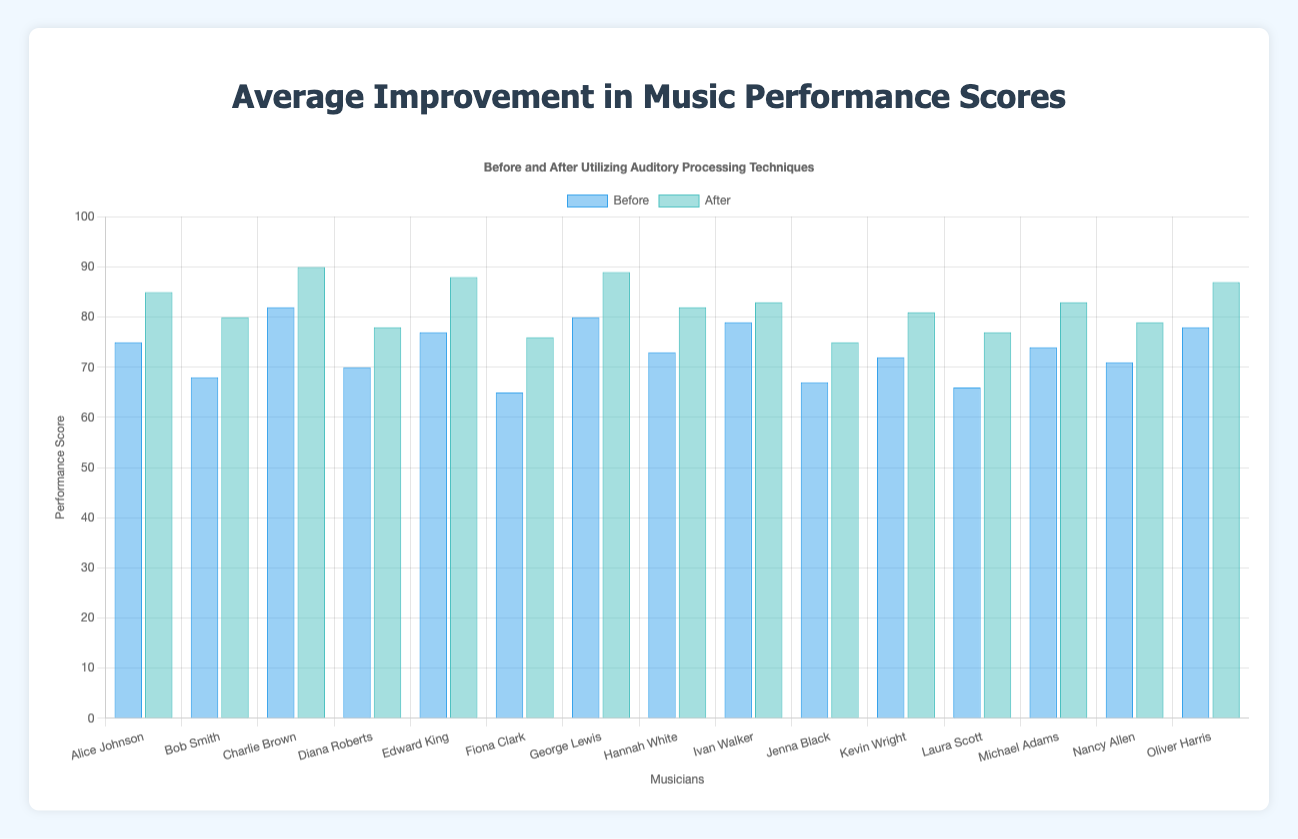Which musician showed the greatest improvement in music performance scores after utilizing auditory processing techniques? To find the greatest improvement, calculate the difference between the "before" and "after" scores for each musician. The largest difference is for Edward King, with an improvement of (88 - 77 = 11 points).
Answer: Edward King What was the average improvement in performance scores for all musicians? To calculate the average improvement, first find the improvement for each musician, sum these improvements, and divide by the number of musicians. Improvements: 10, 12, 8, 8, 11, 11, 9, 9, 4, 8, 9, 11, 9, 8, 9. Sum = 136. Number of musicians = 15. Average improvement = 136 / 15 ≈ 9.07
Answer: 9.07 Which musician had the least improvement in their performance score? Calculate the difference between "before" and "after" scores for each musician. The smallest difference is for Ivan Walker, with an improvement of (83 - 79 = 4 points).
Answer: Ivan Walker How many musicians scored 80 or more after utilizing auditory processing techniques? Count the number of musicians whose "after" scores are 80 or above: Bob Smith, Charlie Brown, Edward King, George Lewis, Oliver Harris, Jenna Black, Kevin Wright, Alice Johnson, Michael Adams. Total = 9 musicians.
Answer: 9 Who was the highest performer both before and after utilizing auditory processing techniques? Identify the highest "before" and "after" scores. Before: Charlie Brown (82), After: Charlie Brown (90).
Answer: Charlie Brown Compare the improvements of Fiona Clark and Laura Scott. Who improved more, and by how much? Calculate the difference in "before" and "after" scores: Fiona Clark (76 - 65 = 11), Laura Scott (77 - 66 = 11). Both improved by the same amount.
Answer: Both improved equally by 11 points What is the total performance score for Bob Smith before and after utilizing auditory processing techniques? Sum the "before" and "after" scores for Bob Smith: 68 + 80 = 148
Answer: 148 Which two musicians have the highest average score before utilizing auditory processing techniques? First calculate the average "before" score for each musician. Identify the two musicians with the highest averages: Charlie Brown (82) and George Lewis (80).
Answer: Charlie Brown and George Lewis 